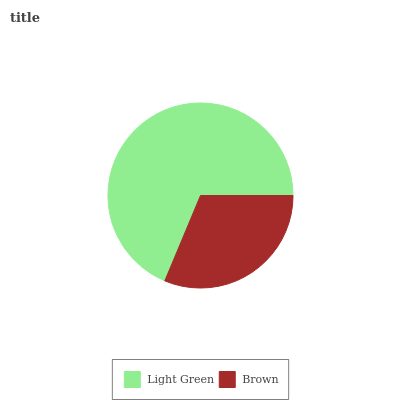Is Brown the minimum?
Answer yes or no. Yes. Is Light Green the maximum?
Answer yes or no. Yes. Is Brown the maximum?
Answer yes or no. No. Is Light Green greater than Brown?
Answer yes or no. Yes. Is Brown less than Light Green?
Answer yes or no. Yes. Is Brown greater than Light Green?
Answer yes or no. No. Is Light Green less than Brown?
Answer yes or no. No. Is Light Green the high median?
Answer yes or no. Yes. Is Brown the low median?
Answer yes or no. Yes. Is Brown the high median?
Answer yes or no. No. Is Light Green the low median?
Answer yes or no. No. 